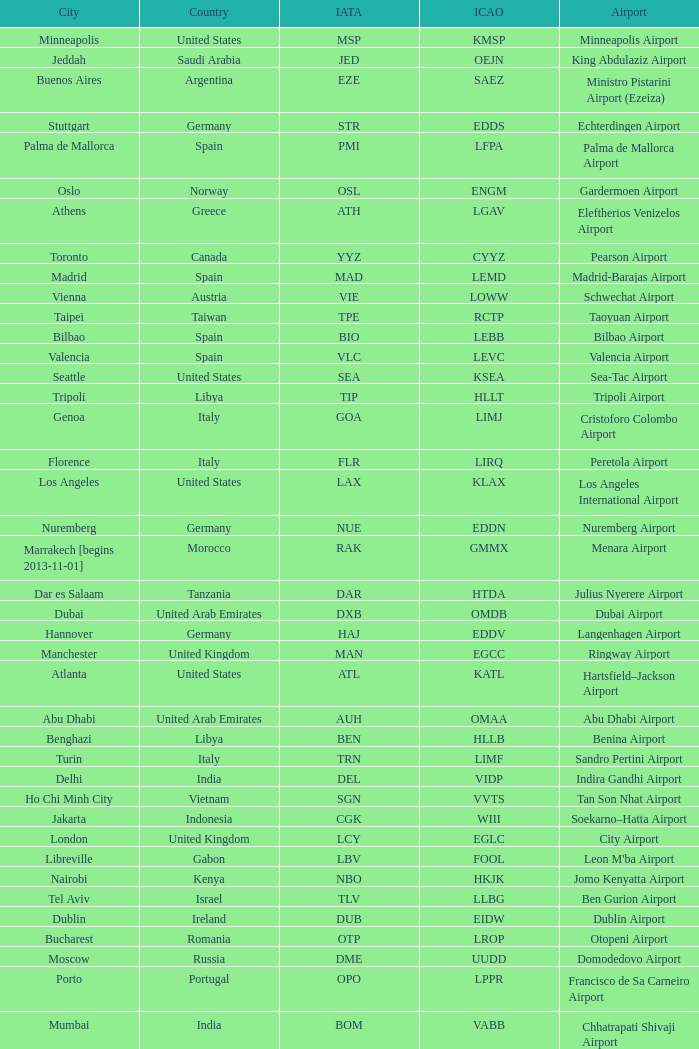What city is fuhlsbüttel airport in? Hamburg. 